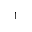Convert formula to latex. <formula><loc_0><loc_0><loc_500><loc_500>^ { 1 }</formula> 